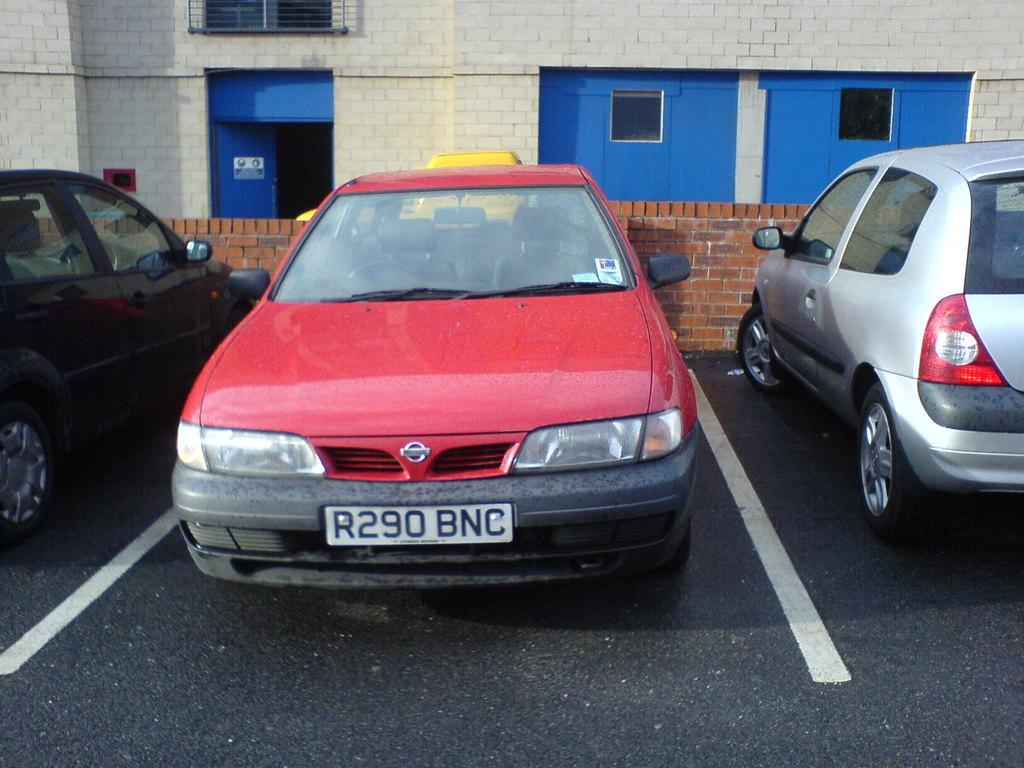How many cars are parked beside the road in the image? There are three cars parked beside the road in the image. What is located behind the road? There is a brick wall behind the road. What can be seen behind the brick wall? There is a building behind the wall. What features does the building have? The building has a door and two windows. How is the distribution of collars among the cars in the image? There is no mention of collars in the image, as it features cars, a brick wall, and a building. What type of home is depicted in the image? The image does not show a home; it shows a building with a door and two windows. 